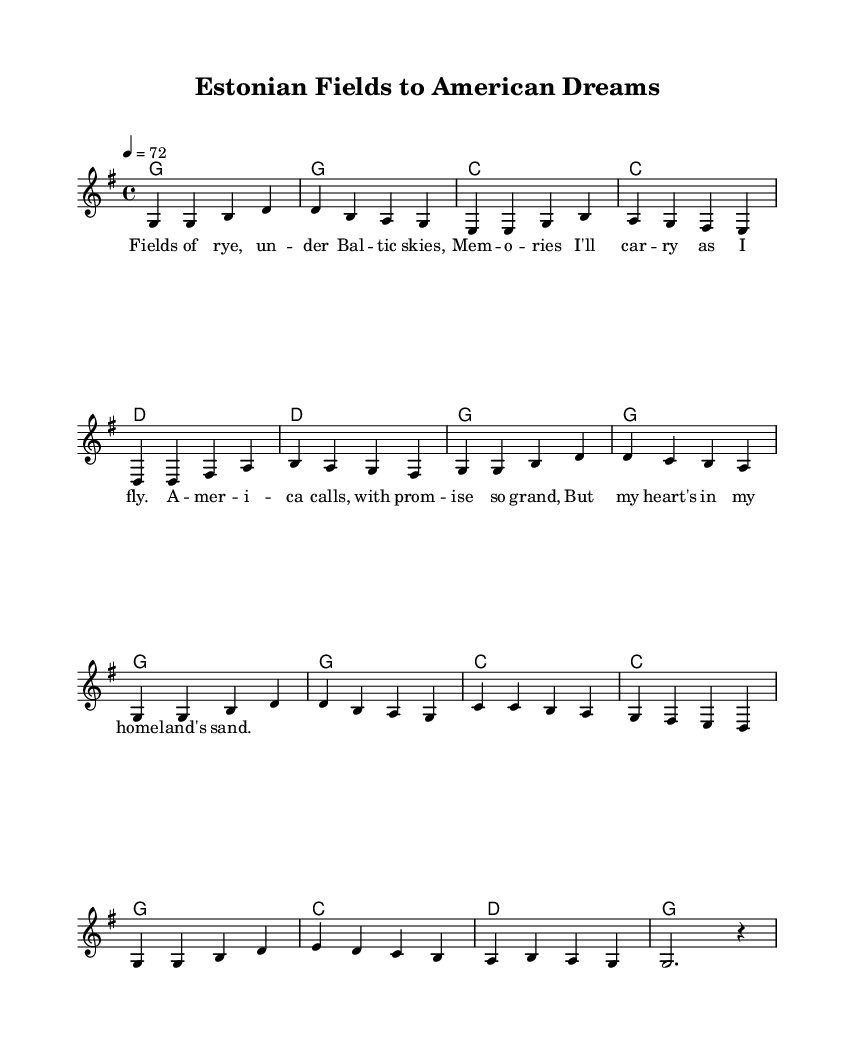What is the key signature of this music? The key signature is indicated at the beginning of the sheet music and shows one sharp (F#), placing it in G major.
Answer: G major What is the time signature of this music? The time signature is shown at the beginning of the sheet music, represented as 4/4, which means there are four beats in each measure and a quarter note gets one beat.
Answer: 4/4 What is the tempo marking for this piece? The tempo marking in the sheet music indicates the speed at which the piece should be played, shown as a quarter note equals 72 beats per minute.
Answer: 72 How many measures are in the piece? By counting the measures indicated by vertical lines on the score, there are a total of 16 measures in this composition.
Answer: 16 What is the first lyric phrase of the song? The first lyric phrase is found under the first measure's melody line, where it reads "Fields of rye, under Baltic skies," which captures the song's reflective theme.
Answer: Fields of rye, under Baltic skies What chords are used in the chorus? The harmony section displays the chords that accompany the melody, and the repeated chords in the chorus are G, C, and D, indicating the foundational harmonic structure.
Answer: G, C, D What musical theme does this piece reflect? This piece reflects a theme of leaving home and starting anew, as indicated by the lyrics which discuss memories and the longing for one's homeland while pursuing dreams in America.
Answer: Leaving home and starting anew 